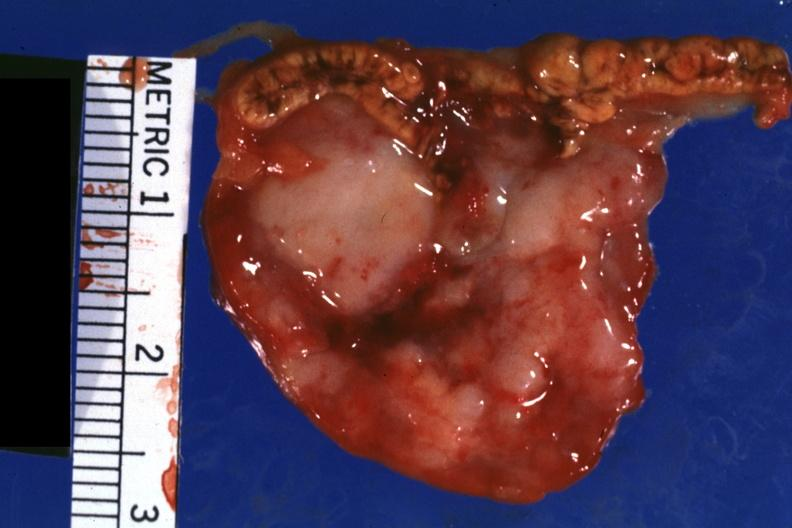s stillborn cord around neck present?
Answer the question using a single word or phrase. No 